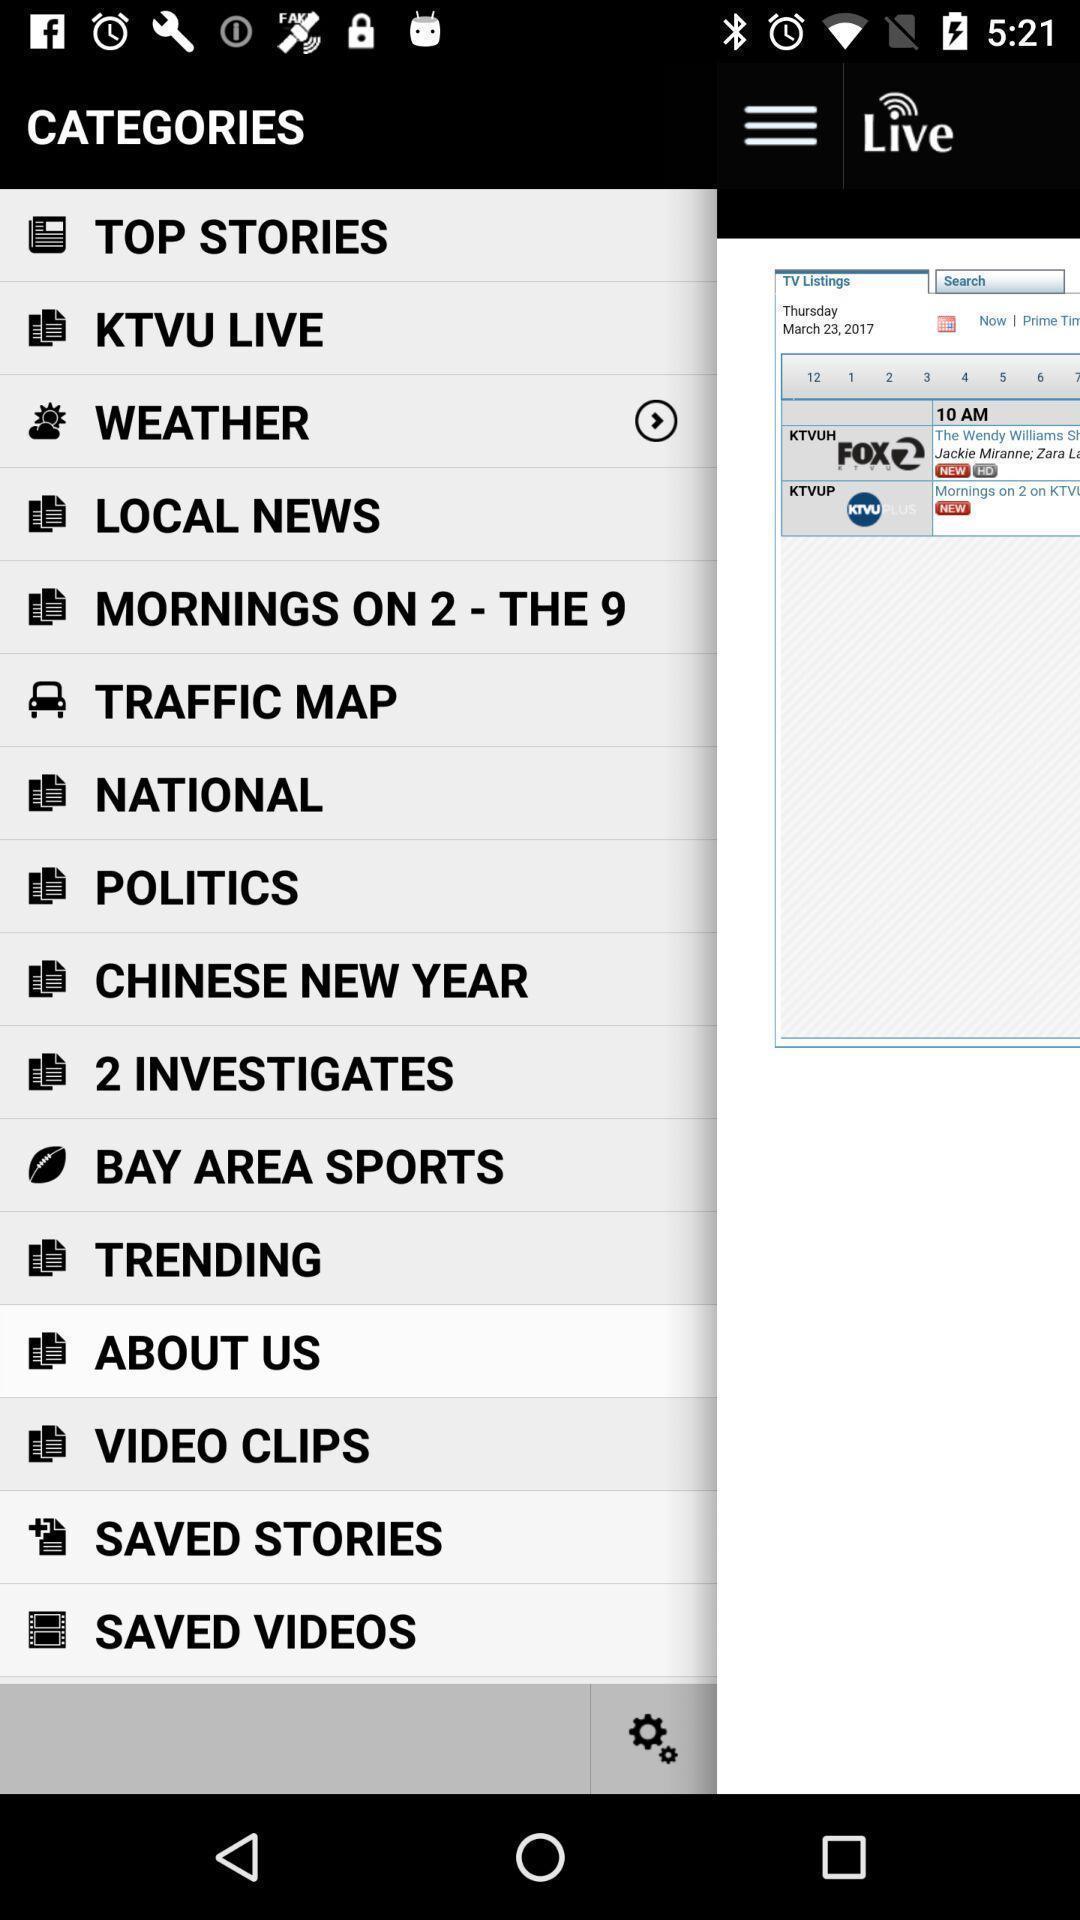Give me a narrative description of this picture. Various categories in a news app. 